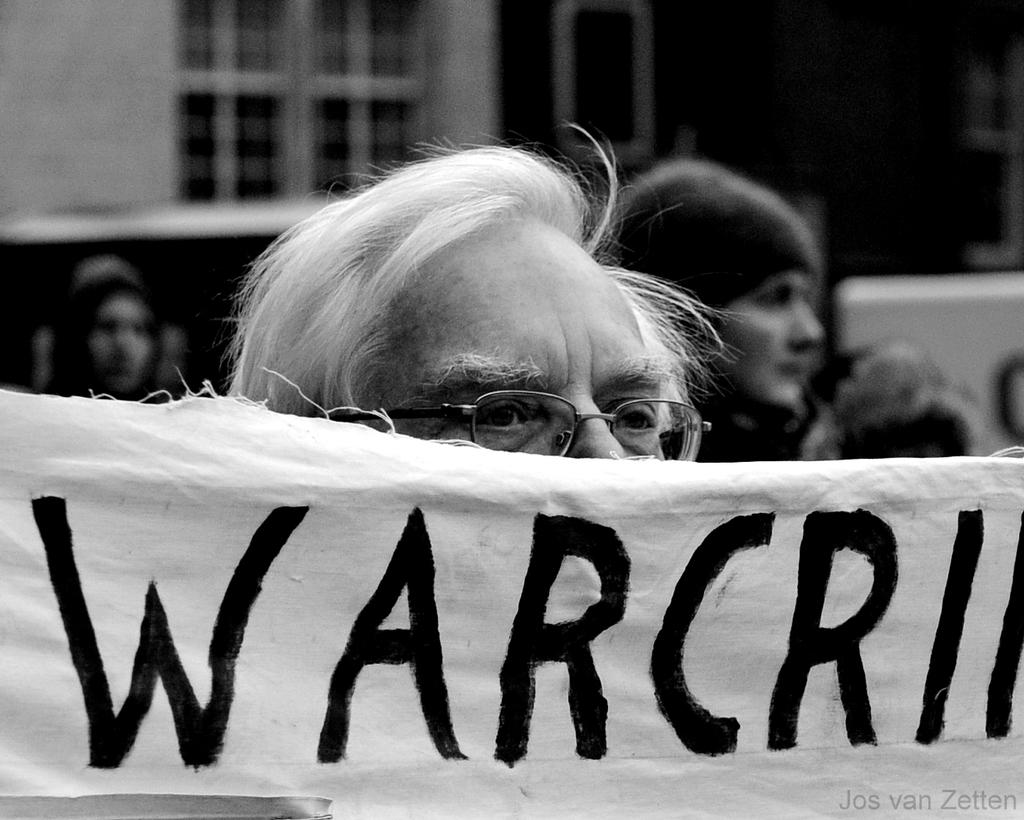Who or what can be seen in the image? There are persons in the image. What else is present in the image besides the persons? There is an advertisement in the image. Can you describe any architectural features in the image? Yes, there are windows in the image. What type of tin can be seen in the image? There is no tin present in the image. What kind of cable is being used by the persons in the image? There is no cable visible in the image. 